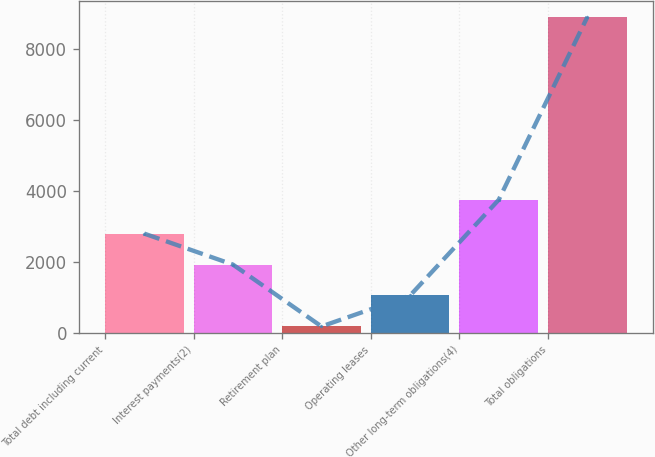Convert chart. <chart><loc_0><loc_0><loc_500><loc_500><bar_chart><fcel>Total debt including current<fcel>Interest payments(2)<fcel>Retirement plan<fcel>Operating leases<fcel>Other long-term obligations(4)<fcel>Total obligations<nl><fcel>2798.46<fcel>1927.04<fcel>184.2<fcel>1055.62<fcel>3750.4<fcel>8898.4<nl></chart> 